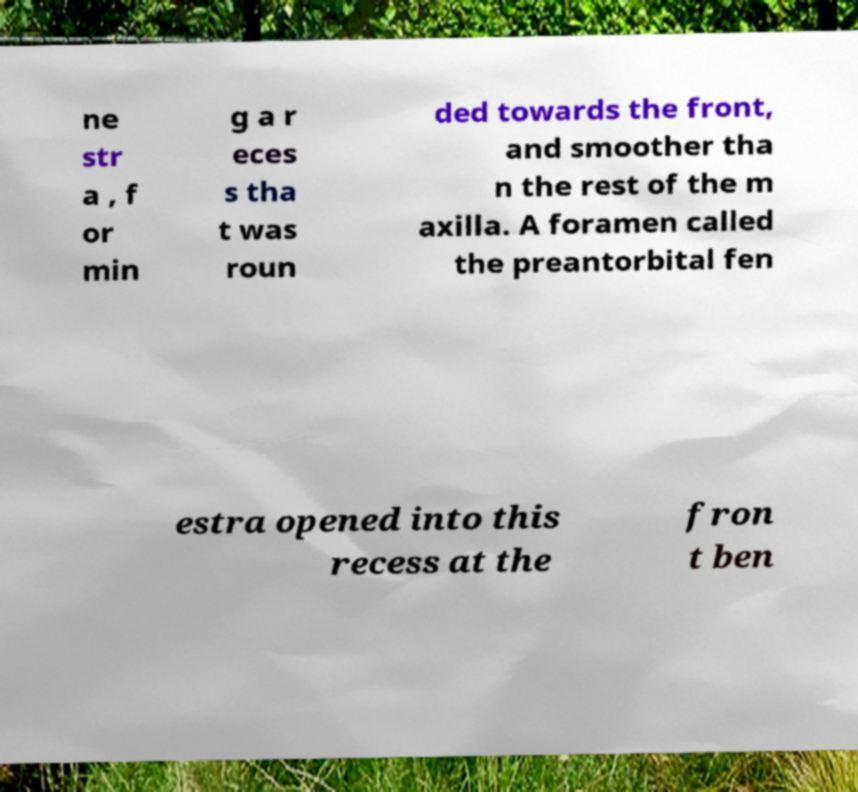Could you extract and type out the text from this image? ne str a , f or min g a r eces s tha t was roun ded towards the front, and smoother tha n the rest of the m axilla. A foramen called the preantorbital fen estra opened into this recess at the fron t ben 